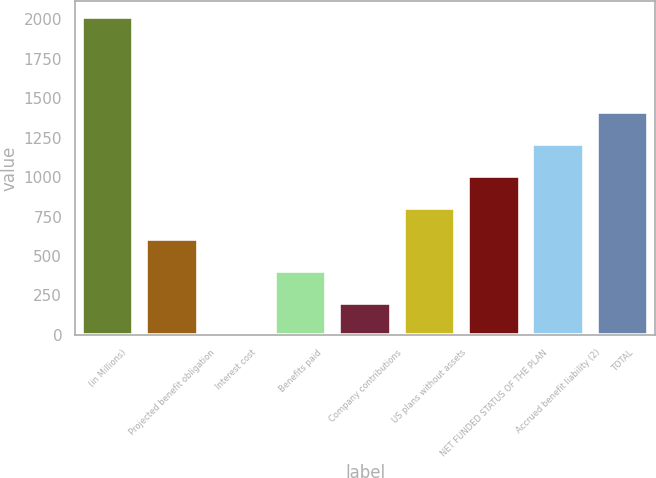Convert chart to OTSL. <chart><loc_0><loc_0><loc_500><loc_500><bar_chart><fcel>(in Millions)<fcel>Projected benefit obligation<fcel>Interest cost<fcel>Benefits paid<fcel>Company contributions<fcel>US plans without assets<fcel>NET FUNDED STATUS OF THE PLAN<fcel>Accrued benefit liability (2)<fcel>TOTAL<nl><fcel>2015<fcel>605.13<fcel>0.9<fcel>403.72<fcel>202.31<fcel>806.54<fcel>1007.95<fcel>1209.36<fcel>1410.77<nl></chart> 